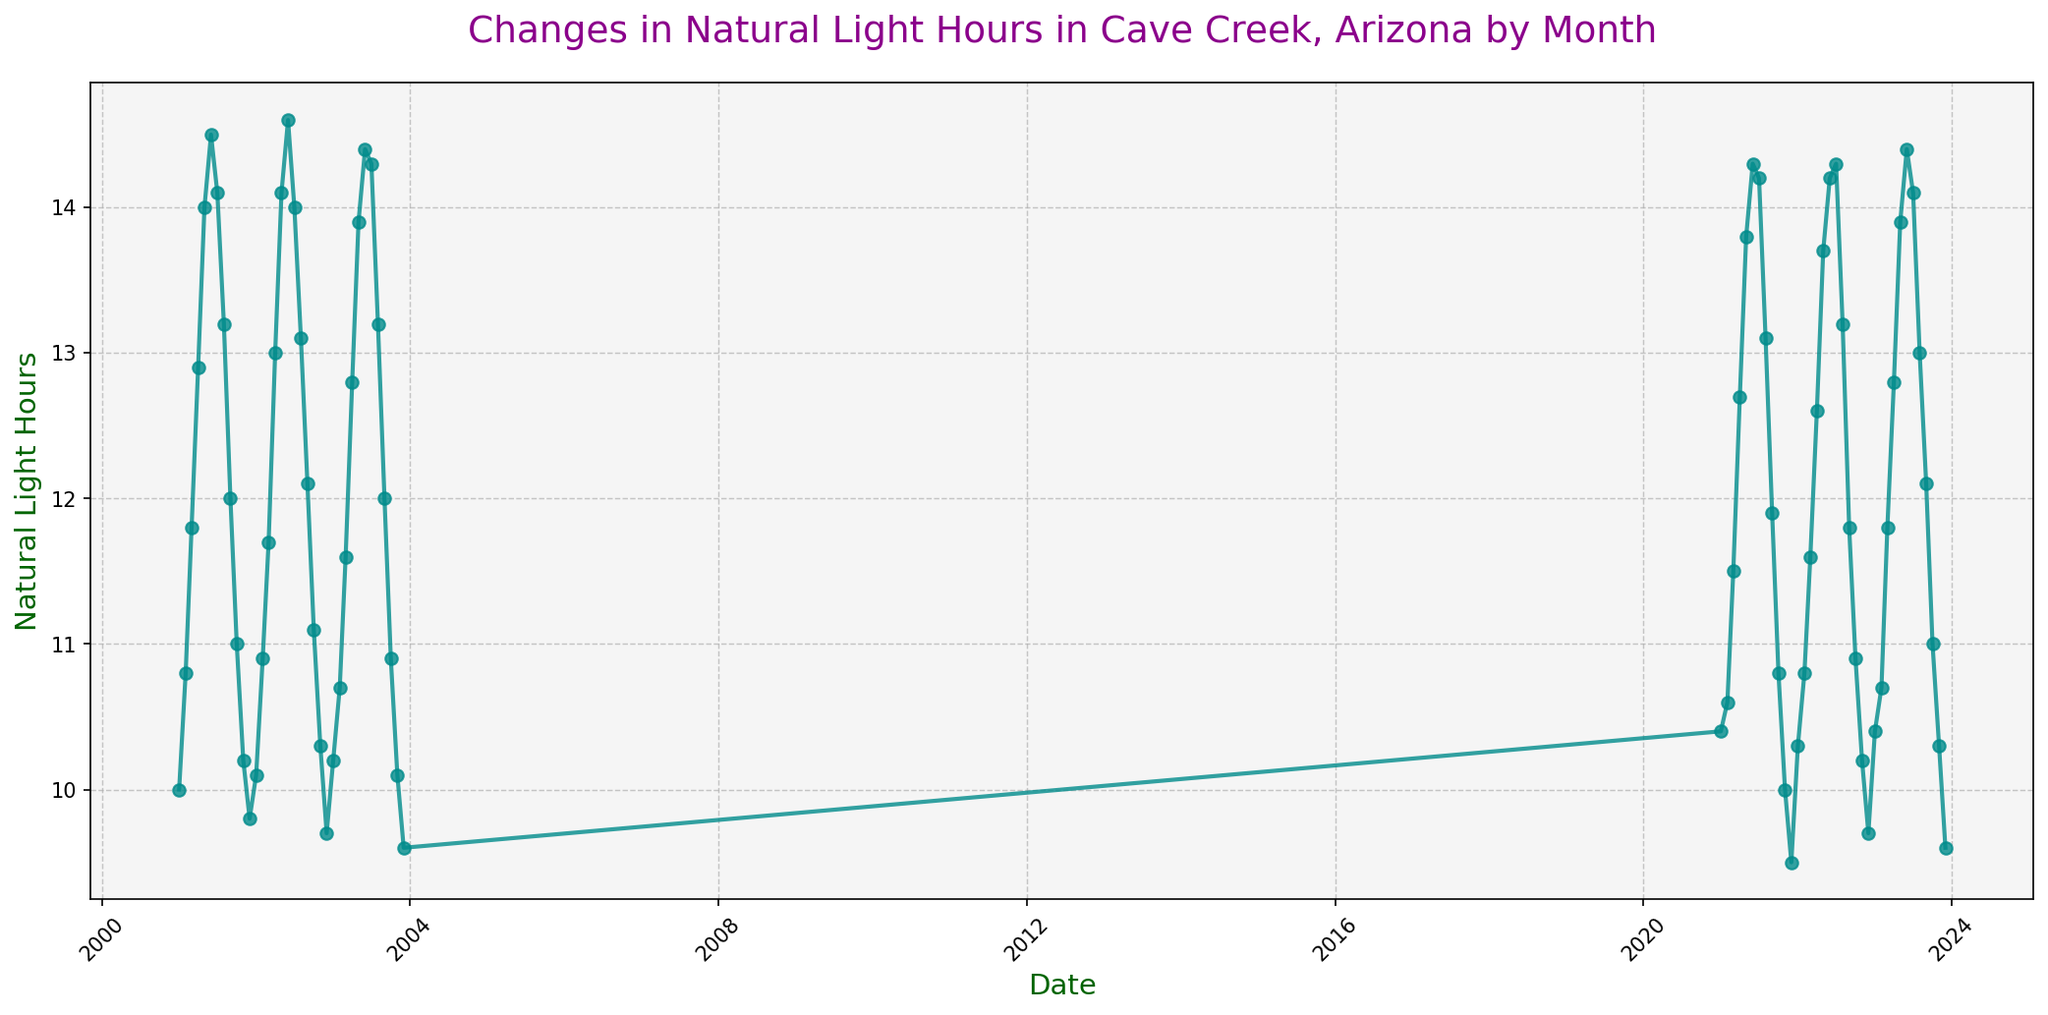Which month in 2023 had the highest number of natural light hours? Look at the data points for 2023 and find the month with the highest peak. June 2023 has the highest value.
Answer: June Which year had a higher average natural light in June, 2001, 2002, or 2003? First, find the June values for 2001, 2002, and 2003, which are 14.5, 14.6, and 14.4 respectively. Compare these values, and 2002 has the highest value.
Answer: 2002 What is the difference between the highest and lowest natural light hours in 2021? Identify the highest value (June, 14.3) and the lowest value (December, 9.5) for 2021. Subtract the lowest from the highest, which gives 14.3 - 9.5.
Answer: 4.8 In what year did April see the highest natural light hours? Identify the April values for the given years: 2001 (12.9), 2002 (13.0), 2003 (12.8), 2021 (12.7), 2022 (12.6), 2023 (12.8). The highest value is 13.0 in 2002.
Answer: 2002 How do the natural light hours in July 2023 compare to those in July 2022? Find the values for July in 2023 and 2022, which are 14.1 and 14.3, respectively. 2022 has higher values compared to 2023.
Answer: 2022 What is the median natural light hours for December across the included years? The December values are 9.8, 9.7, 9.6, 9.5, 9.7, 9.6. Sort these values: 9.5, 9.6, 9.6, 9.7, 9.7, 9.8. The median is the average of the third and fourth values (9.6 and 9.7).
Answer: 9.65 Which month consistently had the least natural light hours? Identify the months with the lowest peaks across the years. December consistently has the lowest values.
Answer: December Is there a general trend in natural light hours from January to June? Observe the data points from January through June over the years; notice that the number of natural light hours increases from January to June consistently.
Answer: Increase 